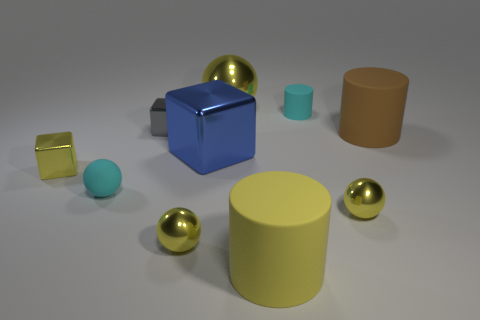Subtract all small cubes. How many cubes are left? 1 Subtract all cyan cylinders. How many yellow spheres are left? 3 Subtract all cyan balls. How many balls are left? 3 Subtract all gray balls. Subtract all yellow cubes. How many balls are left? 4 Subtract all spheres. How many objects are left? 6 Add 4 yellow rubber cylinders. How many yellow rubber cylinders are left? 5 Add 8 tiny blocks. How many tiny blocks exist? 10 Subtract 1 brown cylinders. How many objects are left? 9 Subtract all gray shiny objects. Subtract all tiny cylinders. How many objects are left? 8 